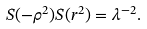<formula> <loc_0><loc_0><loc_500><loc_500>S ( - \rho ^ { 2 } ) S ( r ^ { 2 } ) = \lambda ^ { - 2 } .</formula> 